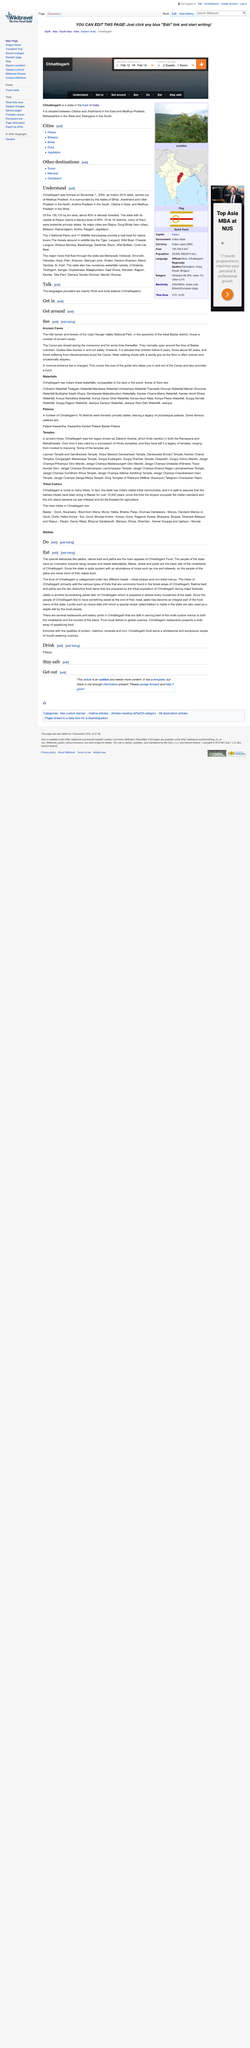Specify some key components in this picture. It can be declared that jalebis and the various types of fruit commonly found in the forest areas of Chhattisgarh are both considered as Chhattisgarh foods, as stated in the text: "Yes, they are. The people of Chhattisgarh are never in shortage of their staple food. The food of Chhattisgarh can be categorized into two main groups: tribal recipes and non-tribal menus. Tribal recipes are traditional dishes prepared by the state's indigenous tribes, using locally sourced ingredients and unique cooking techniques. Non-tribal menus, on the other hand, feature a variety of dishes from different regions of India, with a mix of Indian and international cuisine. 